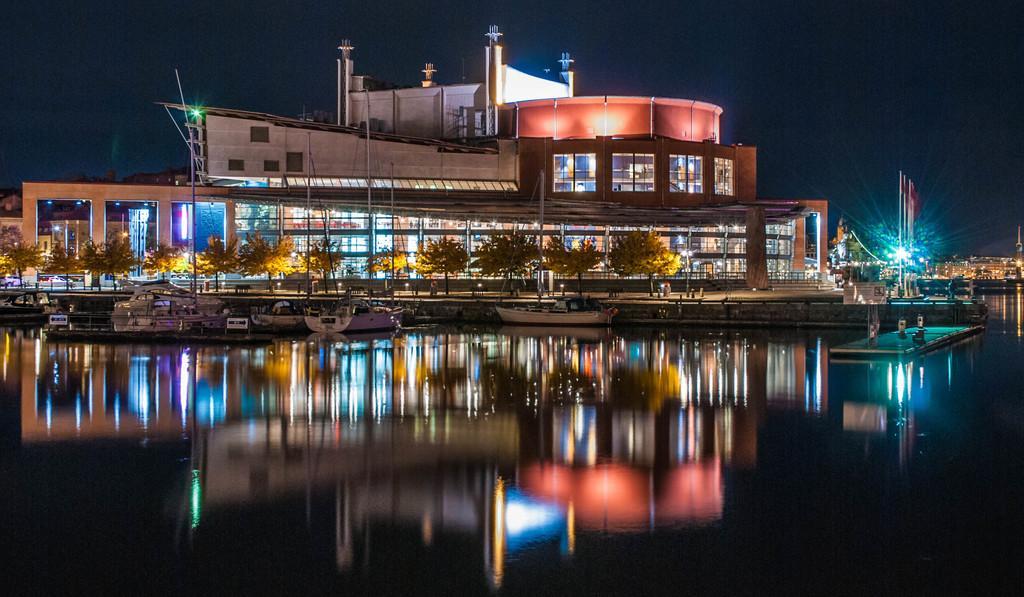In one or two sentences, can you explain what this image depicts? Above this water there are boats. Here we can see buildings, poles, lights and trees. Background there is a dark sky. 